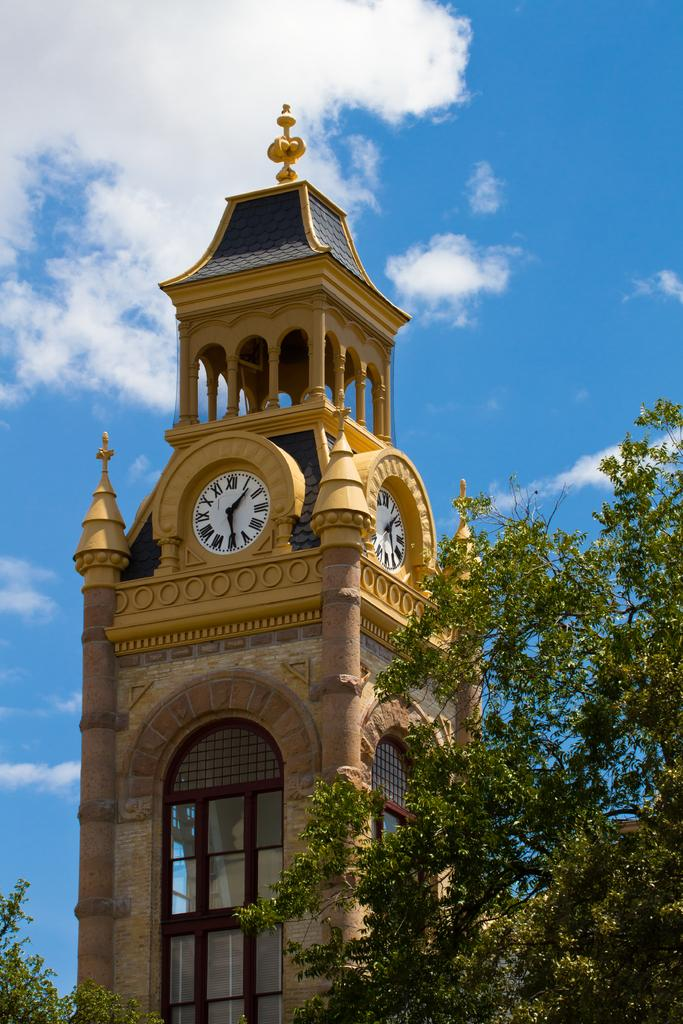What is the main structure in the image? There is a clock tower in the image. What can be seen in the background of the image? There are trees and the sky visible in the background of the image. What is the condition of the sky in the image? Clouds are present in the sky. How many mint leaves are growing on the clock tower in the image? There are no mint leaves present on the clock tower in the image. What is the height of the trees in feet in the image? The facts provided do not give information about the height of the trees or any measurements in feet. 